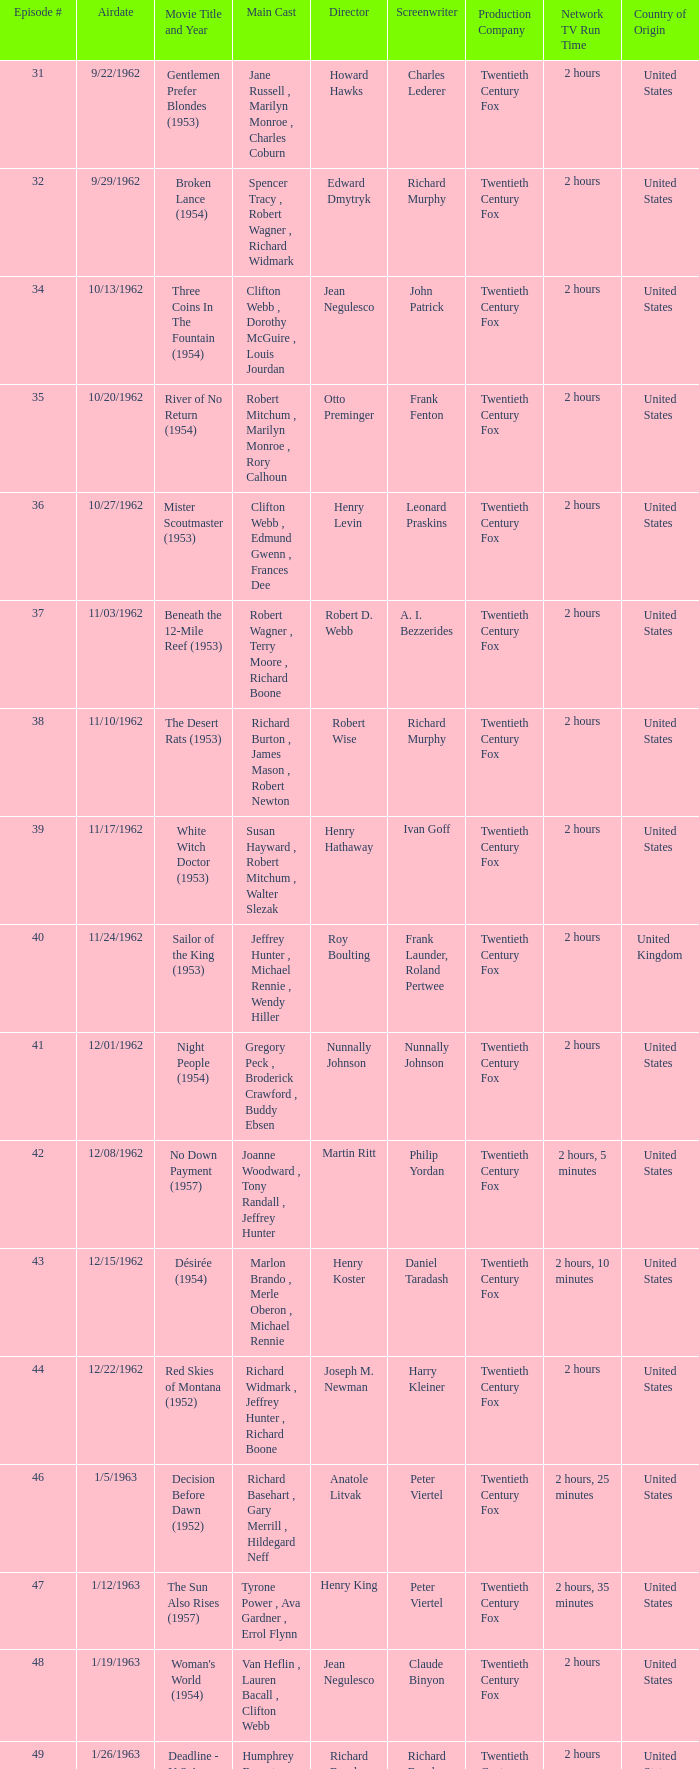How many runtimes does episode 53 have? 1.0. Could you parse the entire table as a dict? {'header': ['Episode #', 'Airdate', 'Movie Title and Year', 'Main Cast', 'Director', 'Screenwriter', 'Production Company', 'Network TV Run Time', 'Country of Origin'], 'rows': [['31', '9/22/1962', 'Gentlemen Prefer Blondes (1953)', 'Jane Russell , Marilyn Monroe , Charles Coburn', 'Howard Hawks', 'Charles Lederer', 'Twentieth Century Fox', '2 hours', 'United States'], ['32', '9/29/1962', 'Broken Lance (1954)', 'Spencer Tracy , Robert Wagner , Richard Widmark', 'Edward Dmytryk', 'Richard Murphy', 'Twentieth Century Fox', '2 hours', 'United States'], ['34', '10/13/1962', 'Three Coins In The Fountain (1954)', 'Clifton Webb , Dorothy McGuire , Louis Jourdan', 'Jean Negulesco', 'John Patrick', 'Twentieth Century Fox', '2 hours', 'United States'], ['35', '10/20/1962', 'River of No Return (1954)', 'Robert Mitchum , Marilyn Monroe , Rory Calhoun', 'Otto Preminger', 'Frank Fenton', 'Twentieth Century Fox', '2 hours', 'United States'], ['36', '10/27/1962', 'Mister Scoutmaster (1953)', 'Clifton Webb , Edmund Gwenn , Frances Dee', 'Henry Levin', 'Leonard Praskins', 'Twentieth Century Fox', '2 hours', 'United States'], ['37', '11/03/1962', 'Beneath the 12-Mile Reef (1953)', 'Robert Wagner , Terry Moore , Richard Boone', 'Robert D. Webb', 'A. I. Bezzerides', 'Twentieth Century Fox', '2 hours', 'United States'], ['38', '11/10/1962', 'The Desert Rats (1953)', 'Richard Burton , James Mason , Robert Newton', 'Robert Wise', 'Richard Murphy', 'Twentieth Century Fox', '2 hours', 'United States'], ['39', '11/17/1962', 'White Witch Doctor (1953)', 'Susan Hayward , Robert Mitchum , Walter Slezak', 'Henry Hathaway', 'Ivan Goff', 'Twentieth Century Fox', '2 hours', 'United States'], ['40', '11/24/1962', 'Sailor of the King (1953)', 'Jeffrey Hunter , Michael Rennie , Wendy Hiller', 'Roy Boulting', 'Frank Launder, Roland Pertwee', 'Twentieth Century Fox', '2 hours', 'United Kingdom'], ['41', '12/01/1962', 'Night People (1954)', 'Gregory Peck , Broderick Crawford , Buddy Ebsen', 'Nunnally Johnson', 'Nunnally Johnson', 'Twentieth Century Fox', '2 hours', 'United States'], ['42', '12/08/1962', 'No Down Payment (1957)', 'Joanne Woodward , Tony Randall , Jeffrey Hunter', 'Martin Ritt', 'Philip Yordan', 'Twentieth Century Fox', '2 hours, 5 minutes', 'United States'], ['43', '12/15/1962', 'Désirée (1954)', 'Marlon Brando , Merle Oberon , Michael Rennie', 'Henry Koster', 'Daniel Taradash', 'Twentieth Century Fox', '2 hours, 10 minutes', 'United States'], ['44', '12/22/1962', 'Red Skies of Montana (1952)', 'Richard Widmark , Jeffrey Hunter , Richard Boone', 'Joseph M. Newman', 'Harry Kleiner', 'Twentieth Century Fox', '2 hours', 'United States'], ['46', '1/5/1963', 'Decision Before Dawn (1952)', 'Richard Basehart , Gary Merrill , Hildegard Neff', 'Anatole Litvak', 'Peter Viertel', 'Twentieth Century Fox', '2 hours, 25 minutes', 'United States'], ['47', '1/12/1963', 'The Sun Also Rises (1957)', 'Tyrone Power , Ava Gardner , Errol Flynn', 'Henry King', 'Peter Viertel', 'Twentieth Century Fox', '2 hours, 35 minutes', 'United States'], ['48', '1/19/1963', "Woman's World (1954)", 'Van Heflin , Lauren Bacall , Clifton Webb', 'Jean Negulesco', 'Claude Binyon', 'Twentieth Century Fox', '2 hours', 'United States'], ['49', '1/26/1963', 'Deadline - U.S.A. (1952)', 'Humphrey Bogart , Kim Hunter , Ed Begley', 'Richard Brooks', 'Richard Brooks', 'Twentieth Century Fox', '2 hours', 'United States'], ['50', '2/2/1963', 'Niagara (1953)', 'Marilyn Monroe , Joseph Cotten , Jean Peters', 'Henry Hathaway', 'Charles Brackett, Walter Reisch, Richard L. Breen', 'Twentieth Century Fox', '2 hours', 'United States'], ['51', '2/9/1963', 'Kangaroo (1952)', "Maureen O'Hara , Peter Lawford , Richard Boone", 'Lewis Milestone', 'Harry Kleiner', 'Twentieth Century Fox', '2 hours', 'United States'], ['52', '2/16/1963', 'The Long Hot Summer (1958)', 'Paul Newman , Joanne Woodward , Orson Wells', 'Martin Ritt', 'Irving Ravetch, Harriet Frank Jr.', 'Twentieth Century Fox', '2 hours, 15 minutes', 'United States'], ['53', '2/23/1963', "The President's Lady (1953)", 'Susan Hayward , Charlton Heston , John McIntire', 'Henry Levin', 'John Patrick', 'Twentieth Century Fox', '2 hours', 'United States'], ['54', '3/2/1963', 'The Roots of Heaven (1958)', 'Errol Flynn , Juliette Greco , Eddie Albert', 'John Huston', 'Romain Gary, Patrick Leigh Fermor', 'Twentieth Century Fox', '2 hours, 25 minutes', 'United States'], ['55', '3/9/1963', 'In Love and War (1958)', 'Robert Wagner , Hope Lange , Jeffrey Hunter', 'Philip Dunne', 'Henry S. Kesler', 'Twentieth Century Fox', '2 hours, 10 minutes', 'United States'], ['56', '3/16/1963', 'A Certain Smile (1958)', 'Rossano Brazzi , Joan Fontaine , Johnny Mathis', 'Jean Negulesco', 'Jay Dratler', 'Twentieth Century Fox', '2 hours, 5 minutes', 'United States'], ['57', '3/23/1963', 'Fraulein (1958)', 'Dana Wynter , Mel Ferrer , Theodore Bikel', 'Henry Koster', 'Leo Townsend', 'Twentieth Century Fox', '2 hours', 'United States'], ['59', '4/6/1963', 'Night and the City (1950)', 'Richard Widmark , Gene Tierney , Herbert Lom', 'Jules Dassin', 'Jo Eisinger, Jules Dassin', 'Twentieth Century Fox', '2 hours', 'United States']]} 